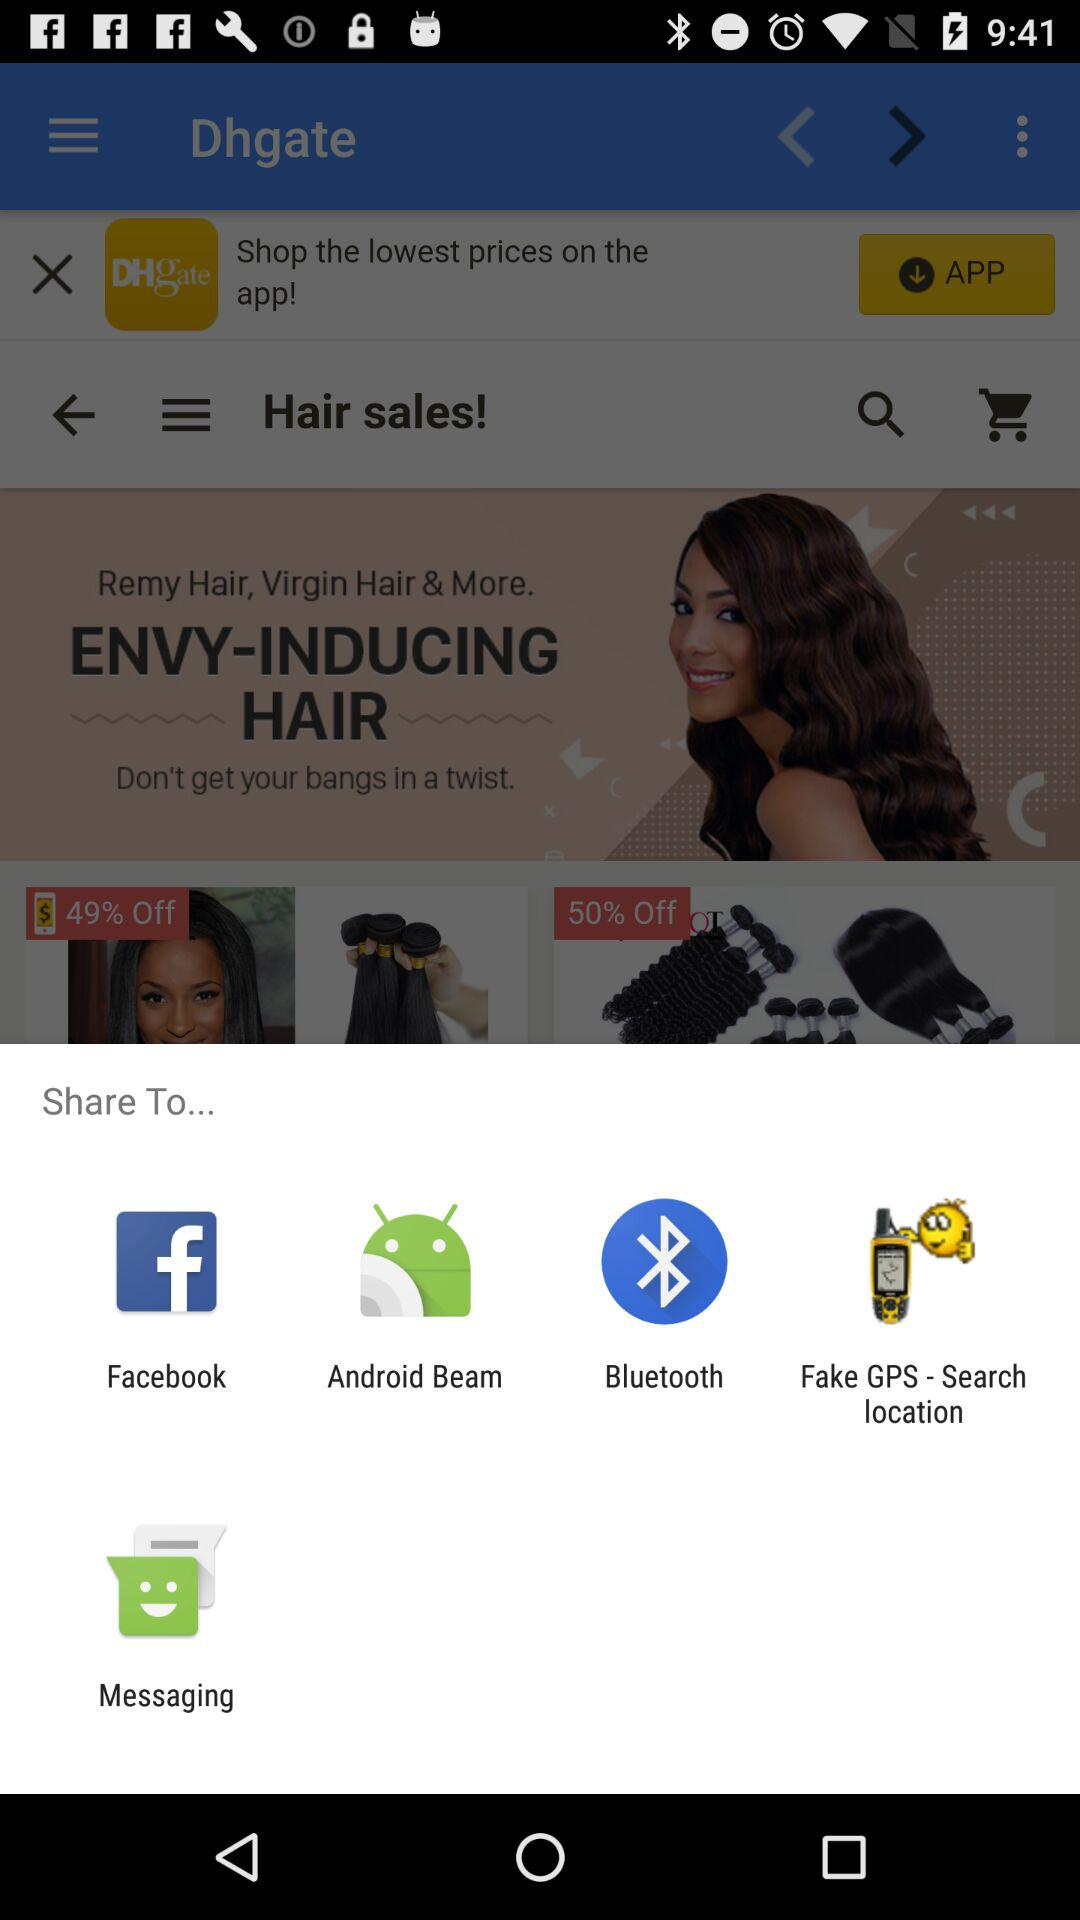What are the sharing options? The sharing options are "Facebook", "Android Beam", "Bluetooth", "Fake GPS - Search location" and "Messaging". 